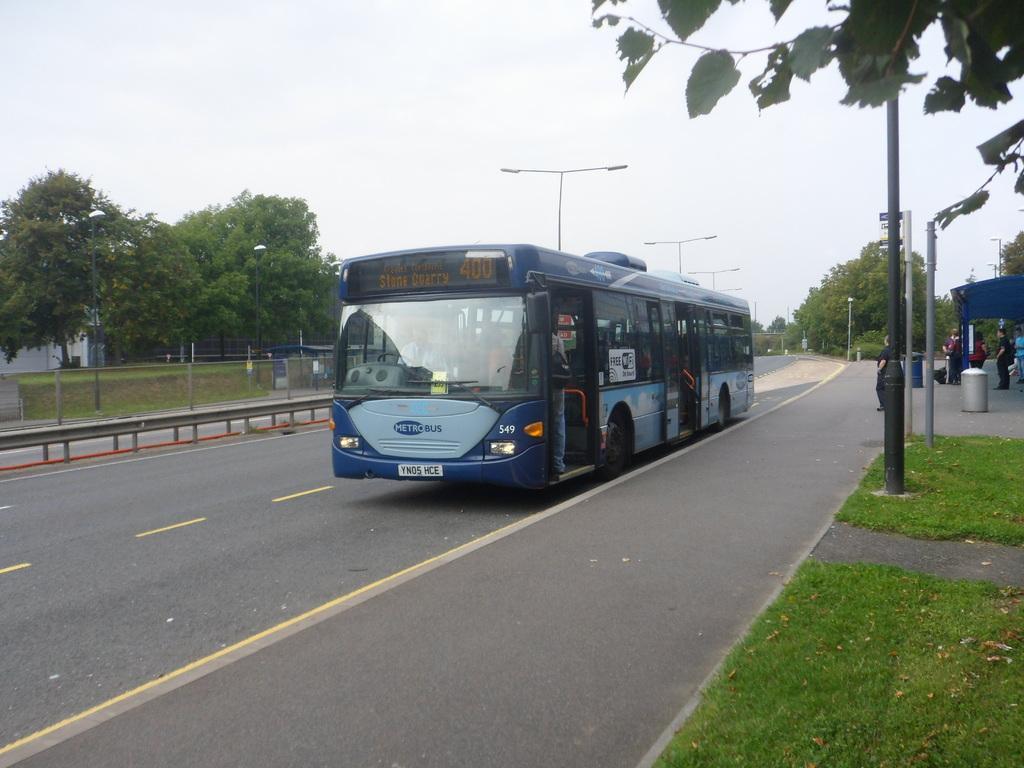In one or two sentences, can you explain what this image depicts? In the center of the image we can see a bus on the road. On the right side of the image there are trees, poles, bus stand and persons. On the left side of the image we can see trees, building and fencing. In the background there is a sky. 